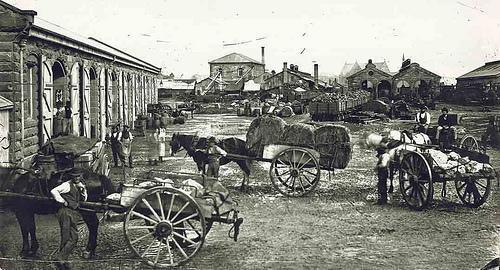How many elephants are facing the camera?
Give a very brief answer. 0. 